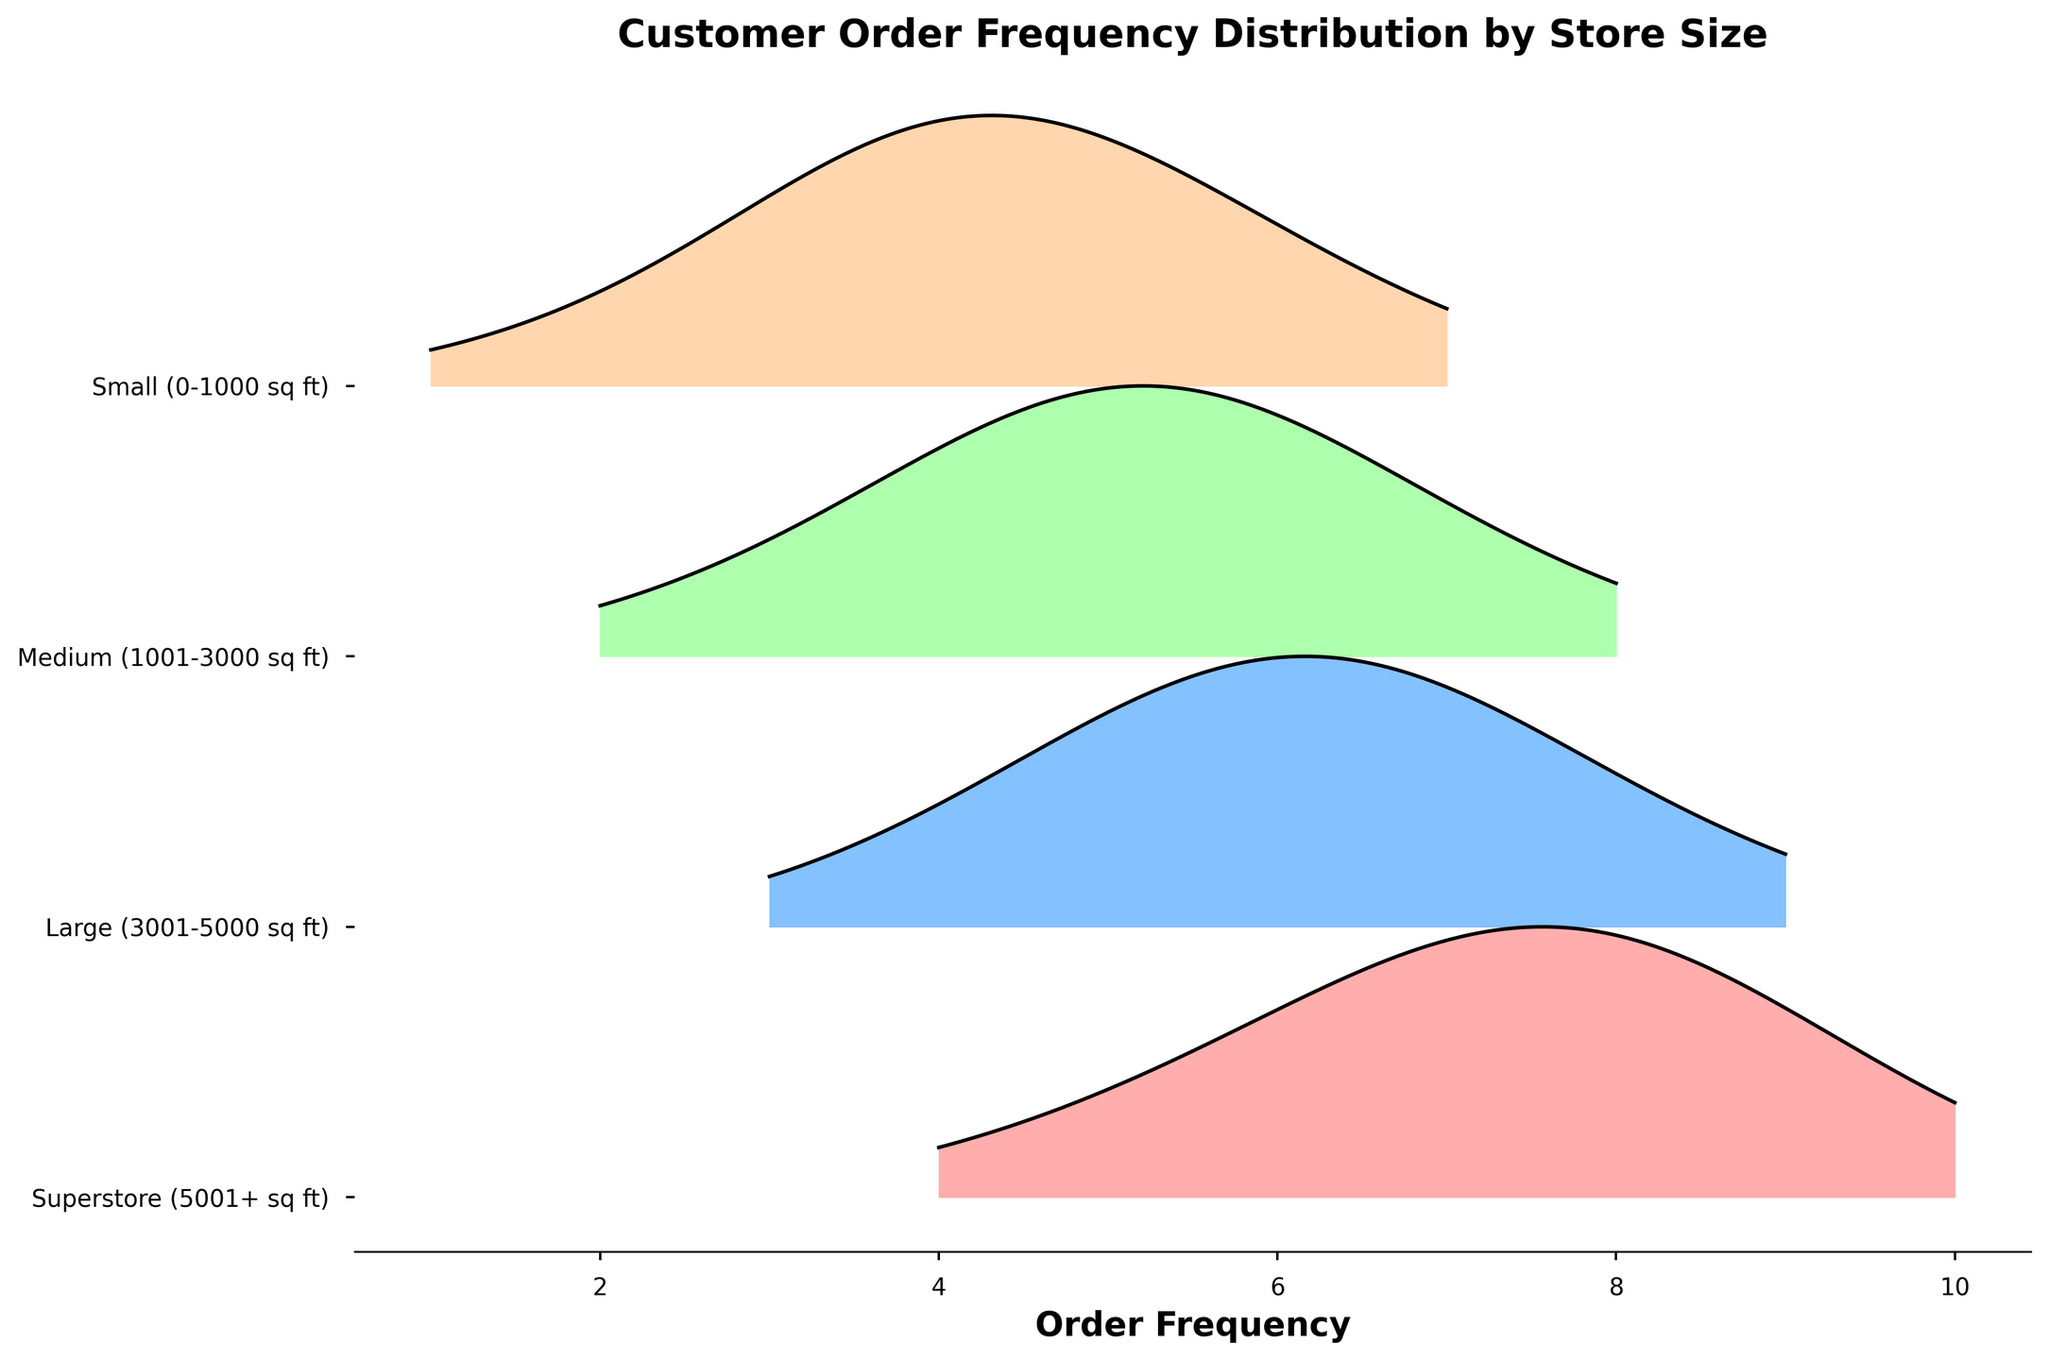What is the title of the plot? The title can be found at the top of the plot. It reads "Customer Order Frequency Distribution by Store Size."
Answer: Customer Order Frequency Distribution by Store Size Which store size category has the highest frequency where the density peaks for "Small (0-1000 sq ft)"? For Small stores, the highest peak occurs at frequency 4.
Answer: 4 What is the order frequency range depicted for the "Large (3001-5000 sq ft)" store size? The frequency values for Large stores range from 3 to 9. By looking at the x-axis and associated ridgeline, the frequencies where data appears for Large stores range between 3 and 9.
Answer: 3 to 9 Is the peak density higher for "Superstore (5001+ sq ft)" or "Medium (1001-3000 sq ft)" stores? By comparing the height of the ridgelines, the density for "Superstore (5001+ sq ft)" appears higher than "Medium (1001-3000 sq ft)."
Answer: Superstore (5001+ sq ft) Which store size category has the latest (right-most) peak in frequency? The latest peak in frequency is for "Superstore (5001+ sq ft)" at frequency 8.
Answer: Superstore (5001+ sq ft) Between "Medium (1001-3000 sq ft)" and "Large (3001-5000 sq ft)" stores, which shows a higher density at a frequency of 5? By inspecting the ridgelines at frequency 5, the "Large (3001-5000 sq ft)" store size shows higher density.
Answer: Large (3001-5000 sq ft) What is the common frequency range that all store sizes share? The common frequency range where all store sizes share is identified by the overlapping x-range areas on the plot. This is from frequency 4 to frequency 7.
Answer: 4 to 7 At what frequencies do "Superstore (5001+ sq ft)" have local density peaks? Observing the plot, "Superstore (5001+ sq ft)" has local density peaks at frequencies 7 and 8.
Answer: 7 and 8 